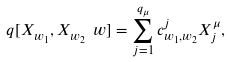Convert formula to latex. <formula><loc_0><loc_0><loc_500><loc_500>\ q [ X _ { w _ { 1 } } , X _ { w _ { 2 } } \ w ] = \sum _ { j = 1 } ^ { q _ { \mu } } c _ { w _ { 1 } , w _ { 2 } } ^ { j } X _ { j } ^ { \mu } ,</formula> 